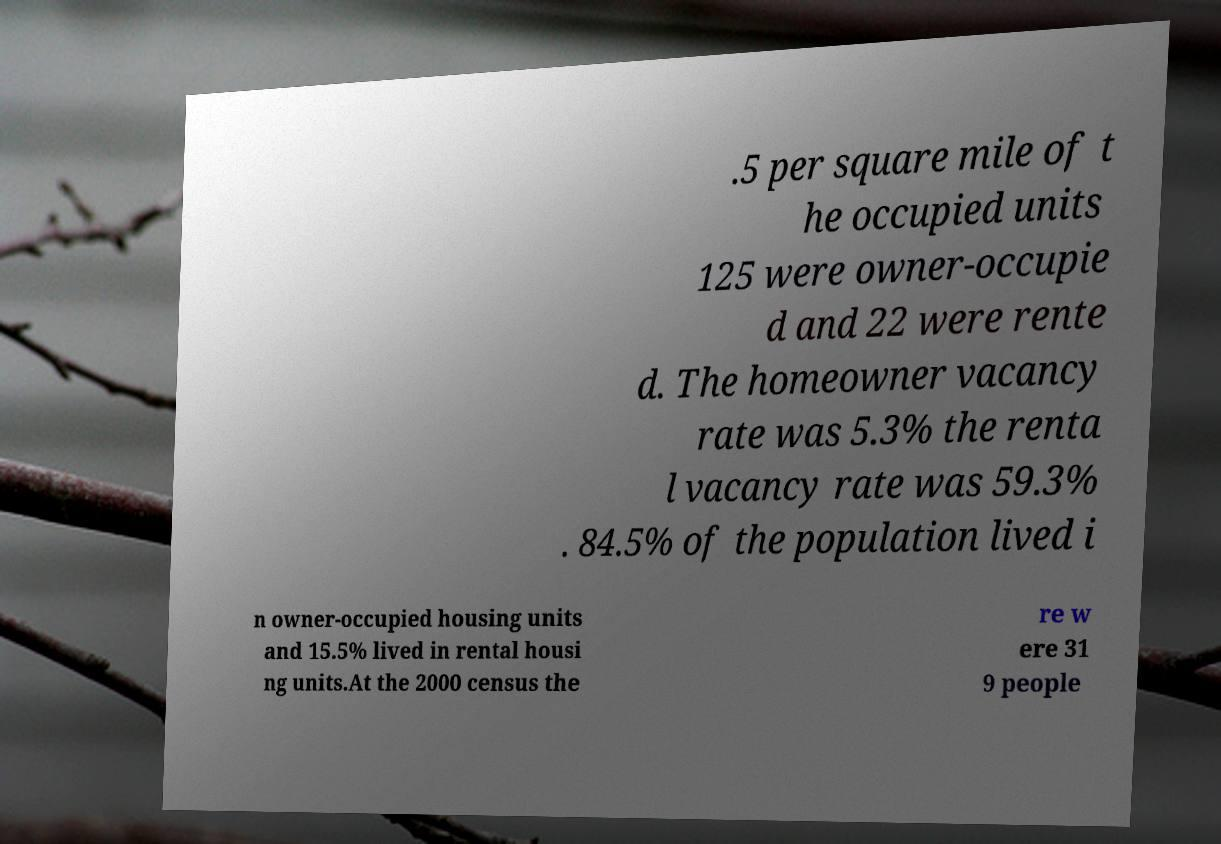What messages or text are displayed in this image? I need them in a readable, typed format. .5 per square mile of t he occupied units 125 were owner-occupie d and 22 were rente d. The homeowner vacancy rate was 5.3% the renta l vacancy rate was 59.3% . 84.5% of the population lived i n owner-occupied housing units and 15.5% lived in rental housi ng units.At the 2000 census the re w ere 31 9 people 